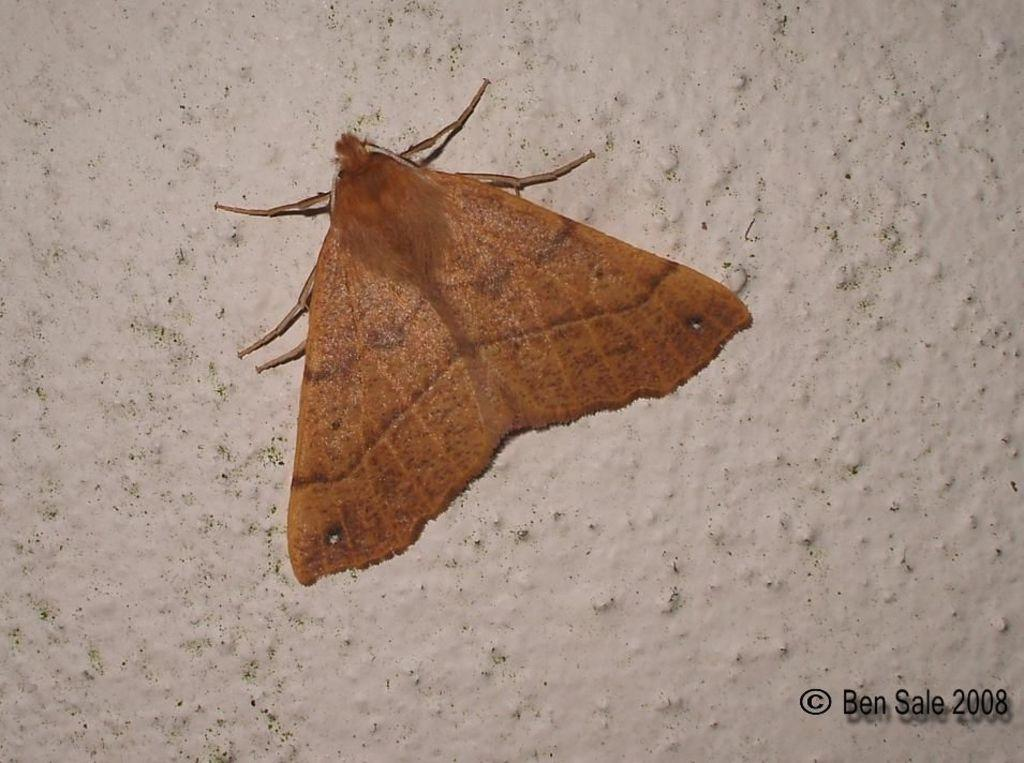What type of creature is in the image? There is an insect in the image. What does the insect resemble? The insect resembles a butterfly. Where is the insect located in the image? The insect is on the wall. What color is the insect? The insect is brown in color. What can be seen in the background of the image? There is a white wall in the background of the image. What type of prose is the insect reciting in the image? There is no indication in the image that the insect is reciting any prose, as insects do not have the ability to speak or recite literature. 